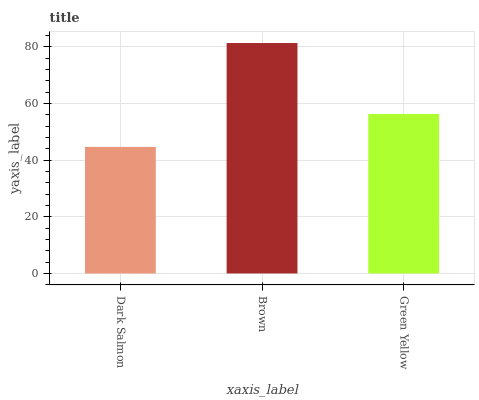Is Dark Salmon the minimum?
Answer yes or no. Yes. Is Brown the maximum?
Answer yes or no. Yes. Is Green Yellow the minimum?
Answer yes or no. No. Is Green Yellow the maximum?
Answer yes or no. No. Is Brown greater than Green Yellow?
Answer yes or no. Yes. Is Green Yellow less than Brown?
Answer yes or no. Yes. Is Green Yellow greater than Brown?
Answer yes or no. No. Is Brown less than Green Yellow?
Answer yes or no. No. Is Green Yellow the high median?
Answer yes or no. Yes. Is Green Yellow the low median?
Answer yes or no. Yes. Is Brown the high median?
Answer yes or no. No. Is Brown the low median?
Answer yes or no. No. 